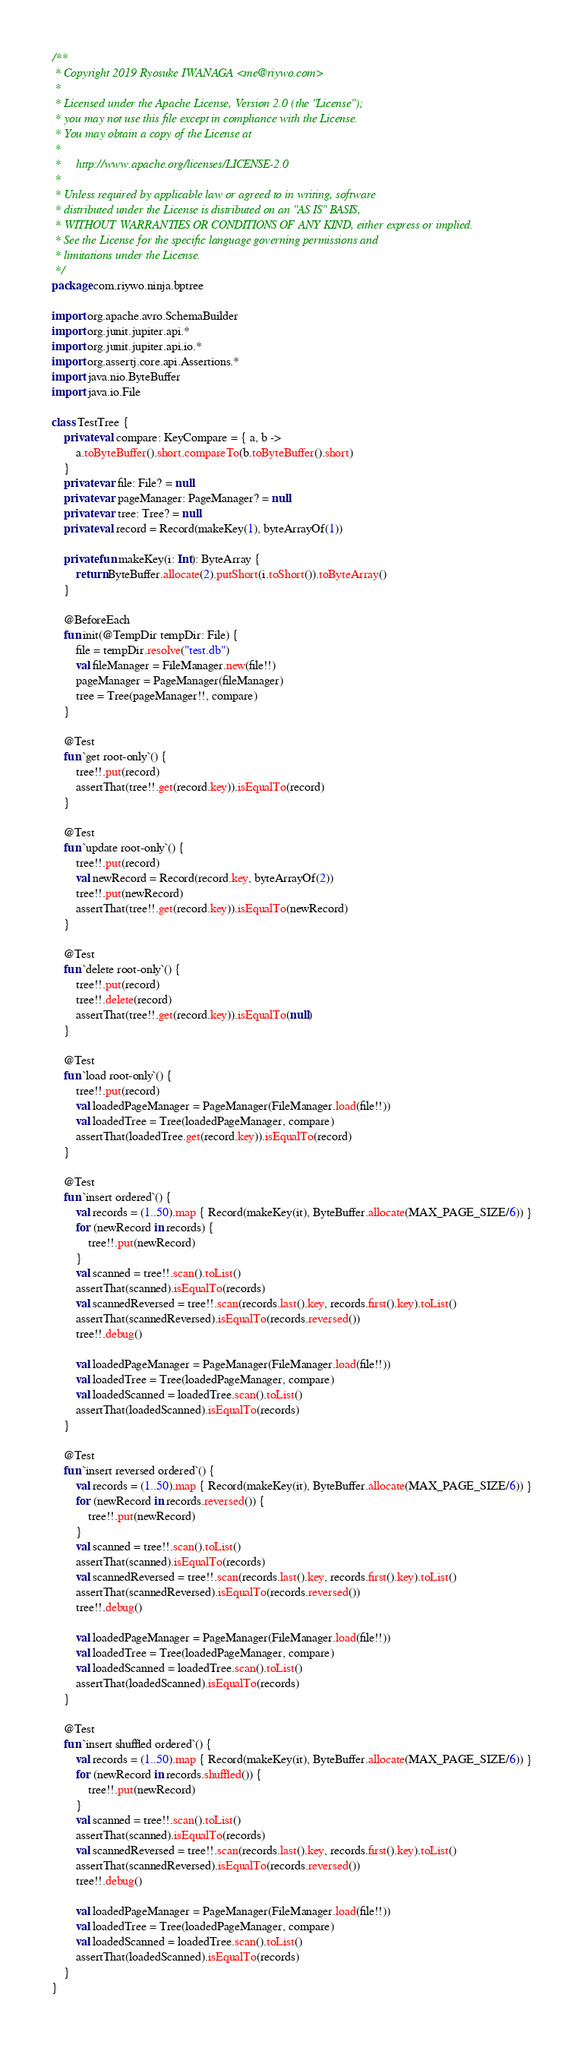Convert code to text. <code><loc_0><loc_0><loc_500><loc_500><_Kotlin_>/**
 * Copyright 2019 Ryosuke IWANAGA <me@riywo.com>
 *
 * Licensed under the Apache License, Version 2.0 (the "License");
 * you may not use this file except in compliance with the License.
 * You may obtain a copy of the License at
 *
 *     http://www.apache.org/licenses/LICENSE-2.0
 *
 * Unless required by applicable law or agreed to in writing, software
 * distributed under the License is distributed on an "AS IS" BASIS,
 * WITHOUT WARRANTIES OR CONDITIONS OF ANY KIND, either express or implied.
 * See the License for the specific language governing permissions and
 * limitations under the License.
 */
package com.riywo.ninja.bptree

import org.apache.avro.SchemaBuilder
import org.junit.jupiter.api.*
import org.junit.jupiter.api.io.*
import org.assertj.core.api.Assertions.*
import java.nio.ByteBuffer
import java.io.File

class TestTree {
    private val compare: KeyCompare = { a, b ->
        a.toByteBuffer().short.compareTo(b.toByteBuffer().short)
    }
    private var file: File? = null
    private var pageManager: PageManager? = null
    private var tree: Tree? = null
    private val record = Record(makeKey(1), byteArrayOf(1))

    private fun makeKey(i: Int): ByteArray {
        return ByteBuffer.allocate(2).putShort(i.toShort()).toByteArray()
    }

    @BeforeEach
    fun init(@TempDir tempDir: File) {
        file = tempDir.resolve("test.db")
        val fileManager = FileManager.new(file!!)
        pageManager = PageManager(fileManager)
        tree = Tree(pageManager!!, compare)
    }

    @Test
    fun `get root-only`() {
        tree!!.put(record)
        assertThat(tree!!.get(record.key)).isEqualTo(record)
    }

    @Test
    fun `update root-only`() {
        tree!!.put(record)
        val newRecord = Record(record.key, byteArrayOf(2))
        tree!!.put(newRecord)
        assertThat(tree!!.get(record.key)).isEqualTo(newRecord)
    }

    @Test
    fun `delete root-only`() {
        tree!!.put(record)
        tree!!.delete(record)
        assertThat(tree!!.get(record.key)).isEqualTo(null)
    }

    @Test
    fun `load root-only`() {
        tree!!.put(record)
        val loadedPageManager = PageManager(FileManager.load(file!!))
        val loadedTree = Tree(loadedPageManager, compare)
        assertThat(loadedTree.get(record.key)).isEqualTo(record)
    }

    @Test
    fun `insert ordered`() {
        val records = (1..50).map { Record(makeKey(it), ByteBuffer.allocate(MAX_PAGE_SIZE/6)) }
        for (newRecord in records) {
            tree!!.put(newRecord)
        }
        val scanned = tree!!.scan().toList()
        assertThat(scanned).isEqualTo(records)
        val scannedReversed = tree!!.scan(records.last().key, records.first().key).toList()
        assertThat(scannedReversed).isEqualTo(records.reversed())
        tree!!.debug()

        val loadedPageManager = PageManager(FileManager.load(file!!))
        val loadedTree = Tree(loadedPageManager, compare)
        val loadedScanned = loadedTree.scan().toList()
        assertThat(loadedScanned).isEqualTo(records)
    }

    @Test
    fun `insert reversed ordered`() {
        val records = (1..50).map { Record(makeKey(it), ByteBuffer.allocate(MAX_PAGE_SIZE/6)) }
        for (newRecord in records.reversed()) {
            tree!!.put(newRecord)
        }
        val scanned = tree!!.scan().toList()
        assertThat(scanned).isEqualTo(records)
        val scannedReversed = tree!!.scan(records.last().key, records.first().key).toList()
        assertThat(scannedReversed).isEqualTo(records.reversed())
        tree!!.debug()

        val loadedPageManager = PageManager(FileManager.load(file!!))
        val loadedTree = Tree(loadedPageManager, compare)
        val loadedScanned = loadedTree.scan().toList()
        assertThat(loadedScanned).isEqualTo(records)
    }

    @Test
    fun `insert shuffled ordered`() {
        val records = (1..50).map { Record(makeKey(it), ByteBuffer.allocate(MAX_PAGE_SIZE/6)) }
        for (newRecord in records.shuffled()) {
            tree!!.put(newRecord)
        }
        val scanned = tree!!.scan().toList()
        assertThat(scanned).isEqualTo(records)
        val scannedReversed = tree!!.scan(records.last().key, records.first().key).toList()
        assertThat(scannedReversed).isEqualTo(records.reversed())
        tree!!.debug()

        val loadedPageManager = PageManager(FileManager.load(file!!))
        val loadedTree = Tree(loadedPageManager, compare)
        val loadedScanned = loadedTree.scan().toList()
        assertThat(loadedScanned).isEqualTo(records)
    }
}</code> 